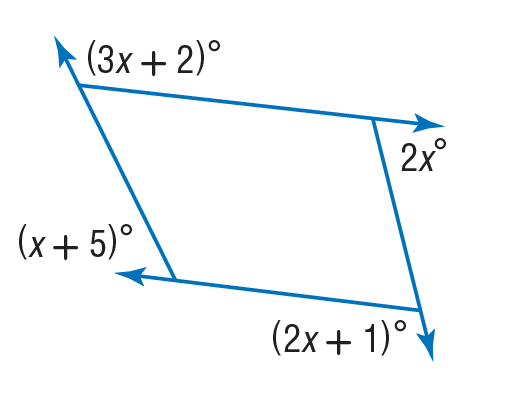Question: Find the value of x in the diagram.
Choices:
A. 44
B. 49
C. 88
D. 132
Answer with the letter. Answer: A 